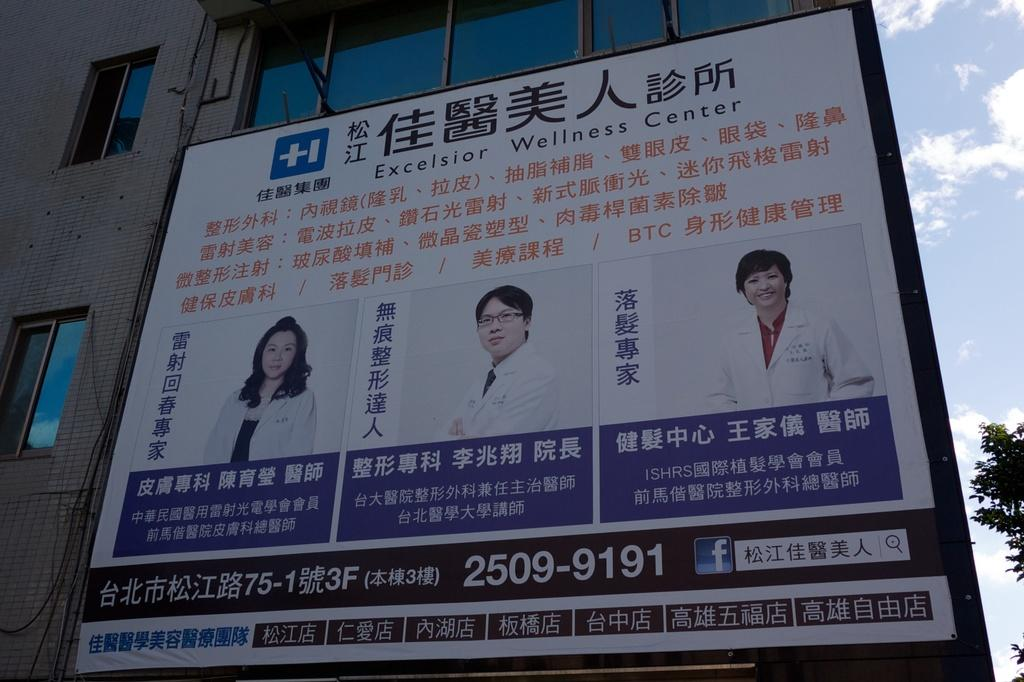<image>
Share a concise interpretation of the image provided. A large Chinese sign near a building with pictures of a woman doctor and two male doctors . 